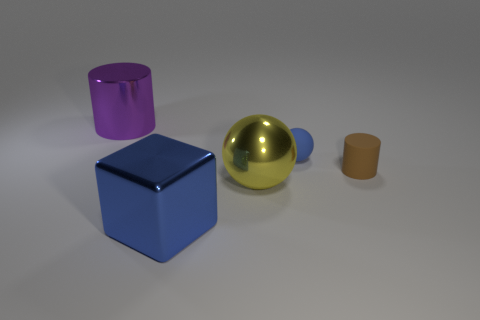Add 4 rubber spheres. How many objects exist? 9 Subtract all cylinders. How many objects are left? 3 Subtract 0 yellow blocks. How many objects are left? 5 Subtract all small yellow rubber spheres. Subtract all blocks. How many objects are left? 4 Add 1 shiny blocks. How many shiny blocks are left? 2 Add 1 small blue rubber balls. How many small blue rubber balls exist? 2 